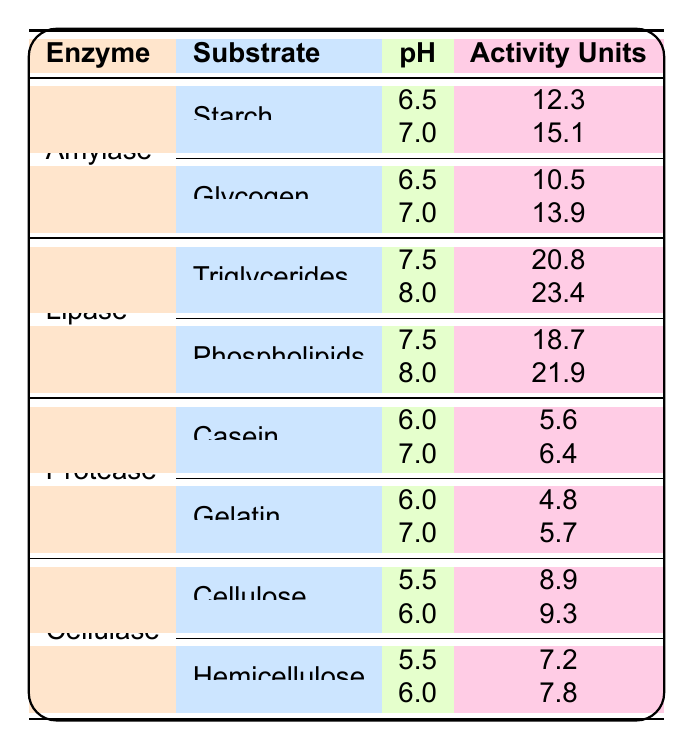What is the enzyme activity of Amylase on Starch at pH 6.5? According to the table, the enzyme Amylase has an activity of 12.3 units when acting on Starch at a pH of 6.5.
Answer: 12.3 What is the highest enzyme activity recorded for Lipase? Looking at the values, Lipase has an activity of 23.4 units when acting on Triglycerides at pH 8.0, which is the highest among all recorded activities for Lipase.
Answer: 23.4 Is the enzyme activity of Protease on Gelatin at pH 6.0 greater than its activity on Casein at pH 6.0? The activity for Protease on Gelatin at pH 6.0 is 4.8, while for Casein at the same pH, it is higher at 5.6. Hence, the statement is false.
Answer: No What is the difference in enzyme activity for Lipase on Phospholipids between pH 7.5 and pH 8.0? The activity of Lipase on Phospholipids at pH 7.5 is 18.7 units, and at pH 8.0, it is 21.9 units. To find the difference, subtract 18.7 from 21.9, which gives 21.9 - 18.7 = 3.2 units.
Answer: 3.2 What's the average enzyme activity of Cellulase on both substrates at pH 5.5? Cellulase has an activity of 8.9 units on Cellulose and 7.2 units on Hemicellulose at pH 5.5. The sum is 8.9 + 7.2 = 16.1, and there are 2 data points. Thus, the average is 16.1 / 2 = 8.05.
Answer: 8.05 Which substrate for Amylase at pH 7.0 has a higher enzyme activity? At pH 7.0, Amylase has an activity of 15.1 units on Starch and 13.9 units on Glycogen. Comparing these two, 15.1 > 13.9, so Starch has the higher activity.
Answer: Starch What is the overall trend in enzyme activity for Protease from pH 6.0 to pH 7.0? At pH 6.0, Protease shows an activity of 5.6 units on Casein and 4.8 units on Gelatin. At pH 7.0, the activities are 6.4 units on Casein and 5.7 units on Gelatin. Both substrates show an increase in activity when moving from pH 6.0 to pH 7.0, indicating a positive trend.
Answer: Positive trend Which enzyme has the lowest activity value across all conditions measured? Reviewing the values for all enzymes, Protease on Gelatin at pH 6.0 has the lowest recorded activity at 4.8 units, making it the lowest across all measurements.
Answer: 4.8 